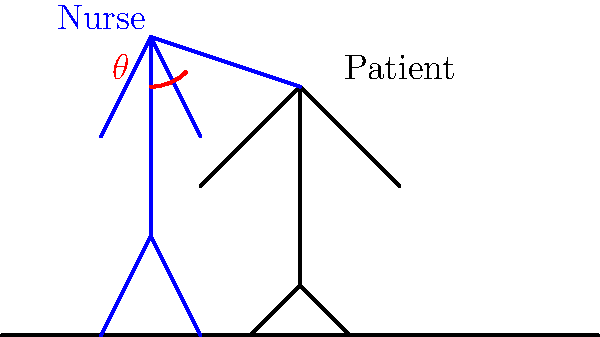In the diagram above, a nurse is preparing to lift a patient using proper biomechanical techniques. If the angle $\theta$ between the nurse's arms and the vertical axis is 45°, what is the ratio of the force applied by the nurse (F_nurse) to the weight of the patient (W_patient) in order to initiate the lift, assuming the patient's center of mass is directly above the point of contact? To solve this problem, we need to follow these steps:

1. Recognize that this is a lever system where the nurse's arms act as the lever, and the point of contact with the patient is the fulcrum.

2. The force applied by the nurse (F_nurse) and the weight of the patient (W_patient) form a right-angled triangle with the nurse's arms.

3. In this triangle:
   - The hypotenuse represents the nurse's arms
   - The adjacent side to angle $\theta$ represents F_nurse
   - The opposite side to angle $\theta$ represents W_patient

4. We can use the trigonometric relationships in this triangle:
   
   $$\tan \theta = \frac{\text{opposite}}{\text{adjacent}} = \frac{W_\text{patient}}{F_\text{nurse}}$$

5. Given $\theta = 45°$, we know that $\tan 45° = 1$

6. Therefore:

   $$1 = \frac{W_\text{patient}}{F_\text{nurse}}$$

7. Rearranging this equation:

   $$F_\text{nurse} = W_\text{patient}$$

8. The ratio of F_nurse to W_patient is thus 1:1 or simply 1.
Answer: 1 